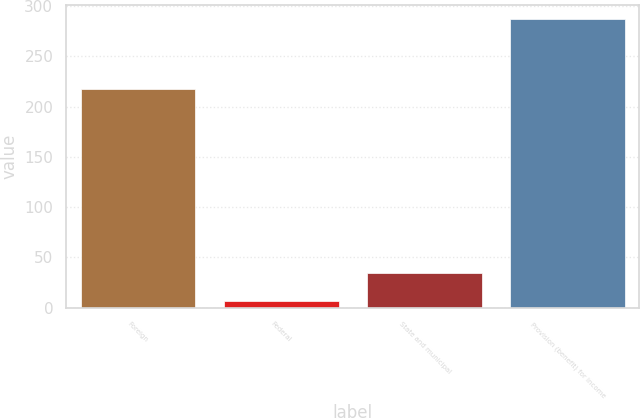Convert chart. <chart><loc_0><loc_0><loc_500><loc_500><bar_chart><fcel>Foreign<fcel>Federal<fcel>State and municipal<fcel>Provision (benefit) for income<nl><fcel>218<fcel>7<fcel>35<fcel>287<nl></chart> 